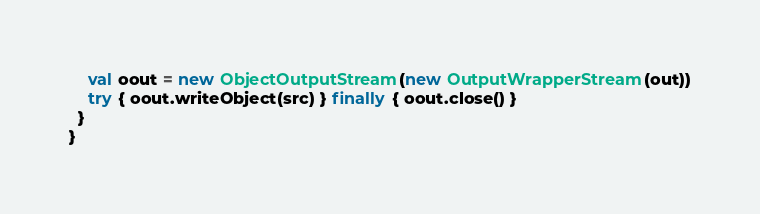Convert code to text. <code><loc_0><loc_0><loc_500><loc_500><_Scala_>    val oout = new ObjectOutputStream(new OutputWrapperStream(out))
    try { oout.writeObject(src) } finally { oout.close() }
  }
}
</code> 